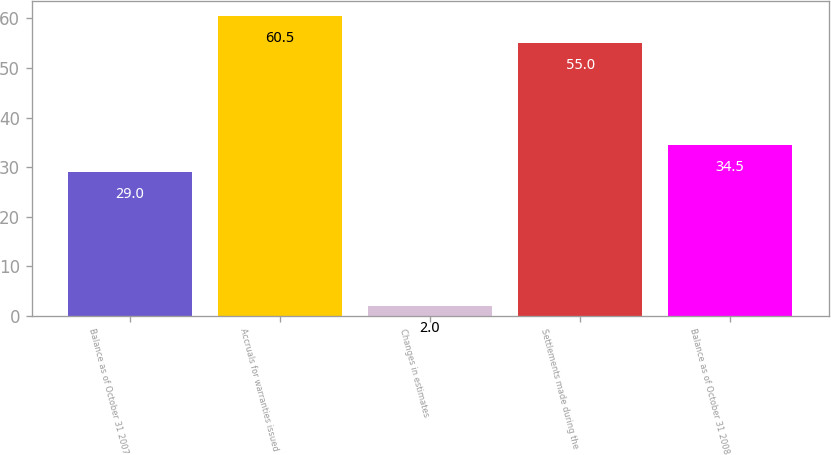<chart> <loc_0><loc_0><loc_500><loc_500><bar_chart><fcel>Balance as of October 31 2007<fcel>Accruals for warranties issued<fcel>Changes in estimates<fcel>Settlements made during the<fcel>Balance as of October 31 2008<nl><fcel>29<fcel>60.5<fcel>2<fcel>55<fcel>34.5<nl></chart> 